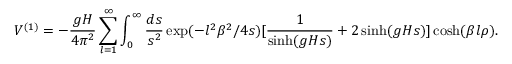<formula> <loc_0><loc_0><loc_500><loc_500>V ^ { ( 1 ) } = - \frac { g H } { 4 \pi ^ { 2 } } \sum _ { l = 1 } ^ { \infty } \int _ { 0 } ^ { \infty } \frac { d s } { s ^ { 2 } } \exp ( - l ^ { 2 } \beta ^ { 2 } / 4 s ) [ \frac { 1 } { \sinh ( g H s ) } + 2 \sinh ( g H s ) ] \cosh ( \beta l \rho ) .</formula> 